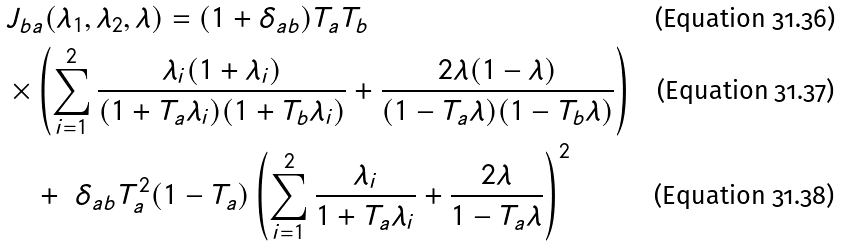Convert formula to latex. <formula><loc_0><loc_0><loc_500><loc_500>& J _ { b a } ( \lambda _ { 1 } , \lambda _ { 2 } , \lambda ) = ( 1 + \delta _ { a b } ) T _ { a } T _ { b } \\ & \times \left ( \sum _ { i = 1 } ^ { 2 } \frac { \lambda _ { i } ( 1 + \lambda _ { i } ) } { ( 1 + T _ { a } \lambda _ { i } ) ( 1 + T _ { b } \lambda _ { i } ) } + \frac { 2 \lambda ( 1 - \lambda ) } { ( 1 - T _ { a } \lambda ) ( 1 - T _ { b } \lambda ) } \right ) \\ & \quad + \ \delta _ { a b } T ^ { 2 } _ { a } ( 1 - T _ { a } ) \left ( \sum _ { i = 1 } ^ { 2 } \frac { \lambda _ { i } } { 1 + T _ { a } \lambda _ { i } } + \frac { 2 \lambda } { 1 - T _ { a } \lambda } \right ) ^ { 2 }</formula> 